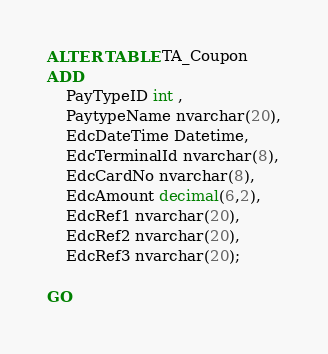<code> <loc_0><loc_0><loc_500><loc_500><_SQL_>ALTER TABLE TA_Coupon
ADD 
    PayTypeID int ,
    PaytypeName nvarchar(20),
	EdcDateTime Datetime,
	EdcTerminalId nvarchar(8),
	EdcCardNo nvarchar(8),
	EdcAmount decimal(6,2),
	EdcRef1 nvarchar(20),
	EdcRef2 nvarchar(20),
	EdcRef3 nvarchar(20);

GO
</code> 